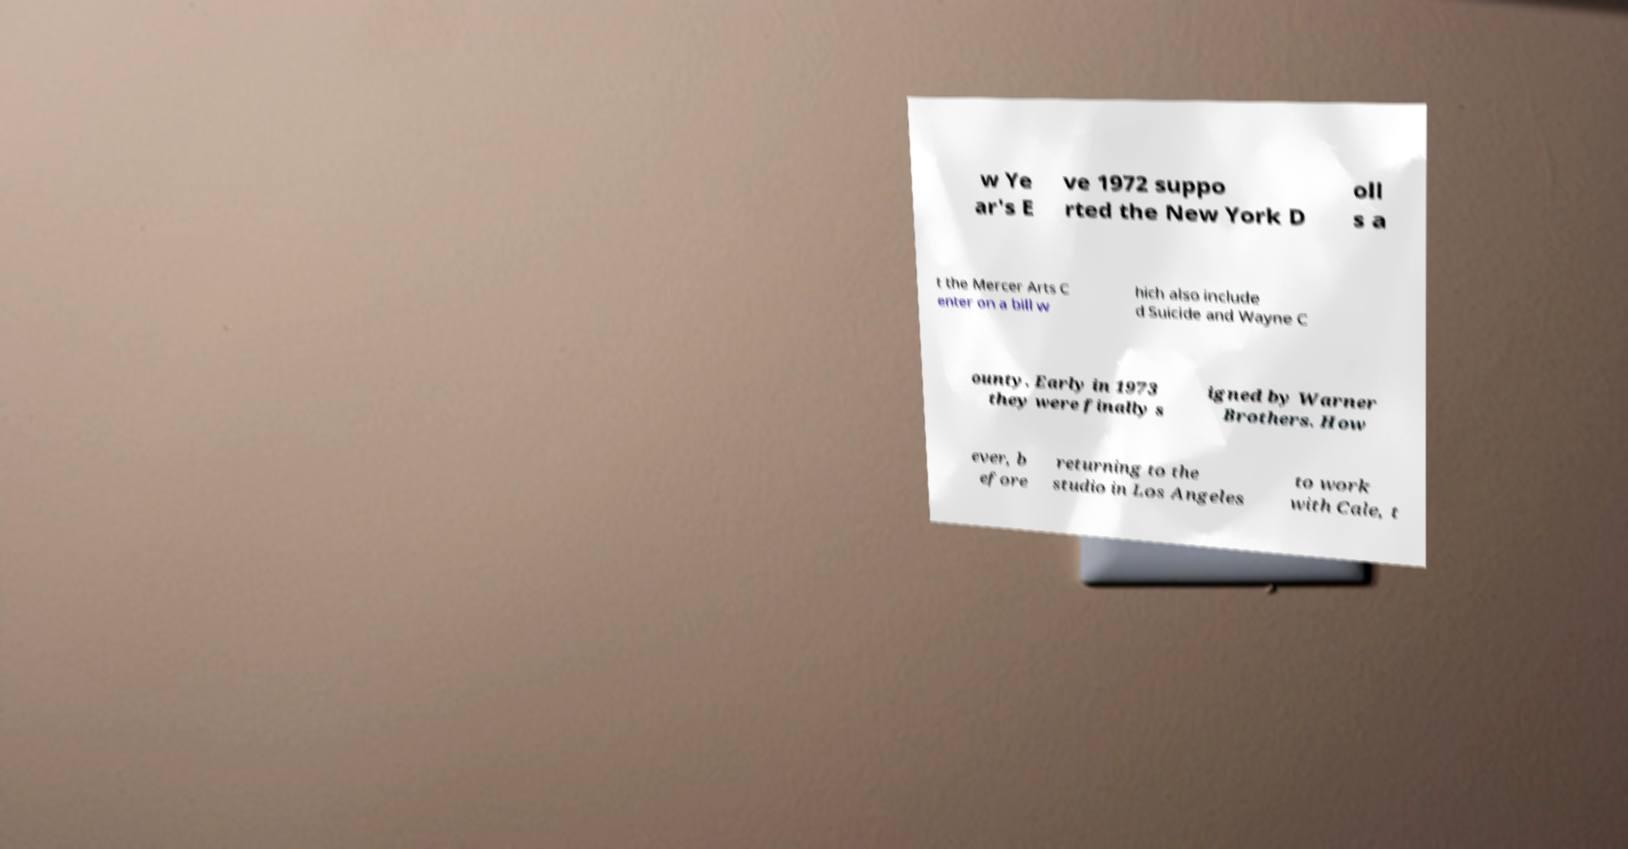For documentation purposes, I need the text within this image transcribed. Could you provide that? w Ye ar's E ve 1972 suppo rted the New York D oll s a t the Mercer Arts C enter on a bill w hich also include d Suicide and Wayne C ounty. Early in 1973 they were finally s igned by Warner Brothers. How ever, b efore returning to the studio in Los Angeles to work with Cale, t 